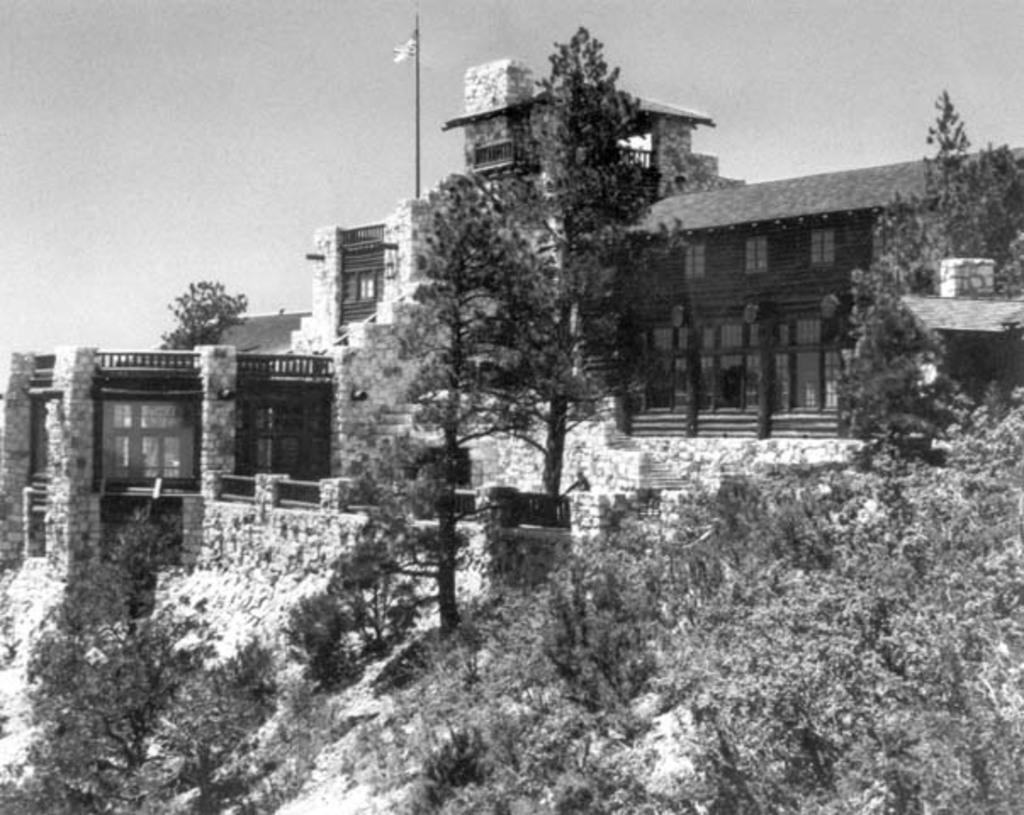What is the color scheme of the image? The image is black and white. What type of structure can be seen in the image? There is a house in the image. What other natural elements are present in the image? There are trees in the image. What is the symbolic object visible in the image? There is a flag in the image. What is visible at the top of the image? The sky is visible at the top of the image. What type of watch can be seen on the side of the house in the image? There is no watch visible on the side of the house in the image. What government policies are being discussed in the image? There is no discussion of government policies in the image; it is a black and white image of a house, trees, a flag, and the sky. 